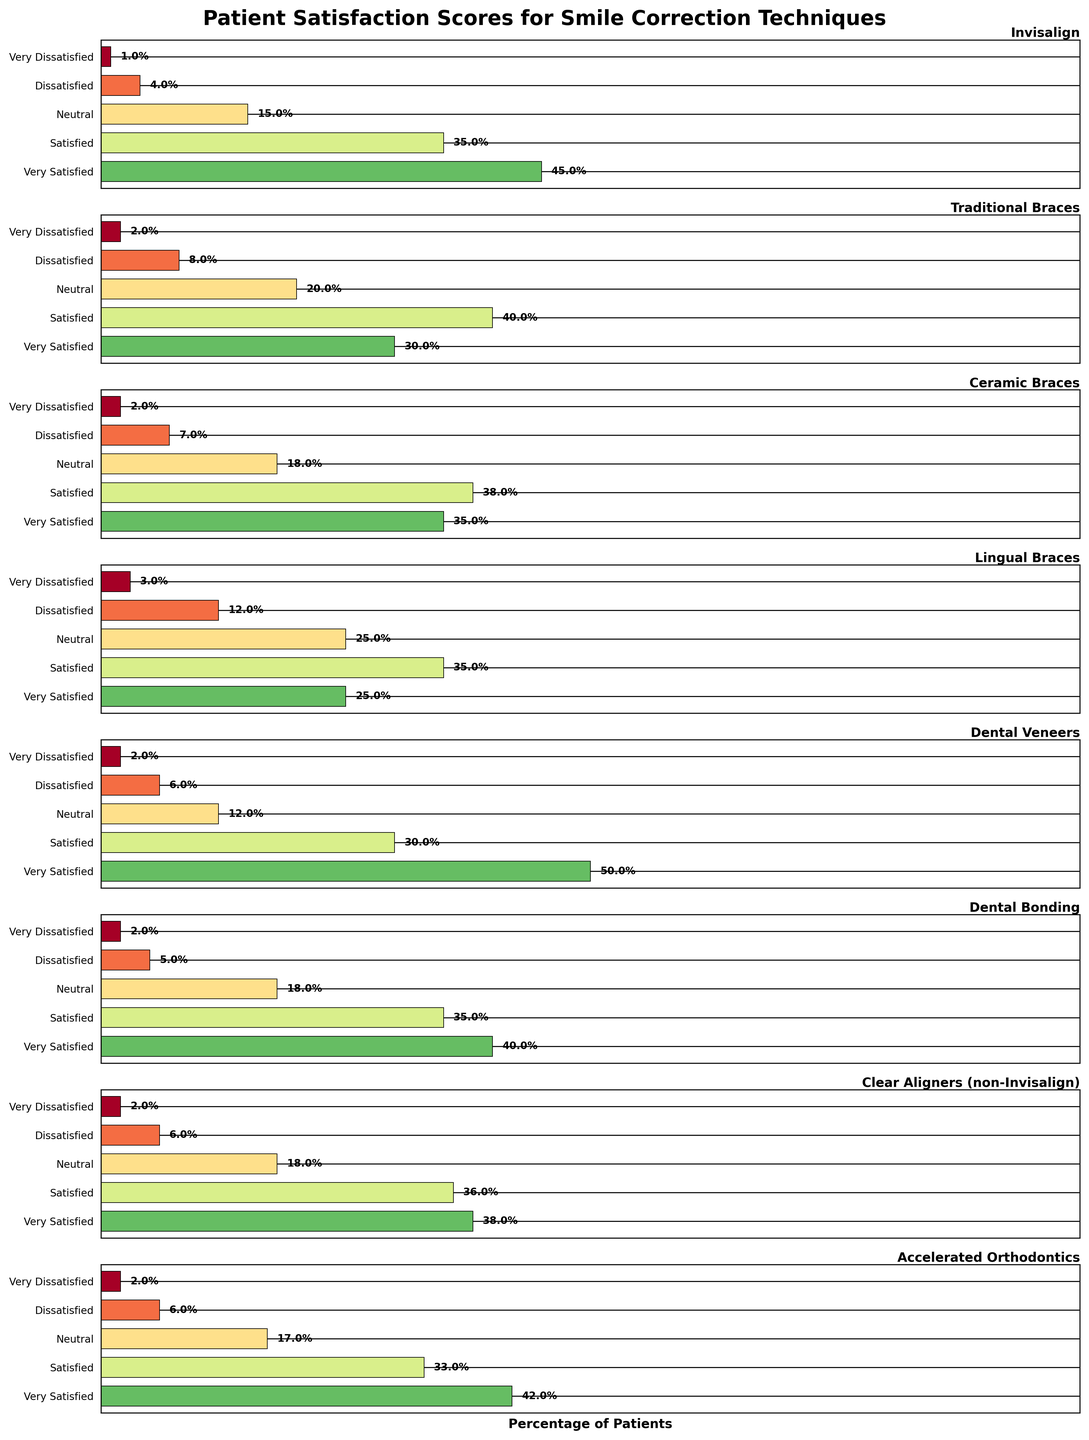How many techniques are compared in the figure? The figure has multiple horizontal subplots, each representing a unique smile correction technique. Count the number of subplots to find the total number of techniques.
Answer: 8 Which smile correction technique has the highest percentage of 'Very Satisfied' patients? By examining each subplot, look at the percentage values for the 'Very Satisfied' category and identify the highest one.
Answer: Dental Veneers What is the total percentage of 'Satisfied' and 'Very Satisfied' patients for Invisalign? From the Invisalign subplot, add the percentages of 'Very Satisfied' and 'Satisfied' patients (45% + 35%).
Answer: 80% Which smile correction technique has the largest percentage of patients who are 'Neutral'? Compare the 'Neutral' category across all subplots and find the technique with the highest percentage.
Answer: Lingual Braces Are there any techniques where the combined percentage of 'Dissatisfied' and 'Very Dissatisfied' patients is 10% or higher? Check the combined percentages for 'Dissatisfied' and 'Very Dissatisfied' in each subplot (e.g., for Traditional Braces: 8% + 2% = 10%) and identify which techniques meet the criteria.
Answer: Traditional Braces, Lingual Braces Between Dental Bonding and Ceramic Braces, which technique has a higher level of patient satisfaction in the 'Very Satisfied' category? Compare the 'Very Satisfied' percentages between Dental Bonding and Ceramic Braces (40% vs. 35%).
Answer: Dental Bonding Which technique has the lowest percentage of 'Very Dissatisfied' patients? Identify the lowest percentage value in the 'Very Dissatisfied' category across all subplots.
Answer: Invisalign What percentage of patients are 'Dissatisfied' with Dental Veneers? Refer to the percentage in the 'Dissatisfied' category in the Dental Veneers subplot.
Answer: 6% How does the 'Satisfied' percentage of Clear Aligners (non-Invisalign) compare to that of Accelerated Orthodontics? Compare the 'Satisfied' percentages for Clear Aligners (non-Invisalign) and Accelerated Orthodontics (36% vs. 33%).
Answer: Clear Aligners (non-Invisalign) has higher 'Satisfied' percentage 